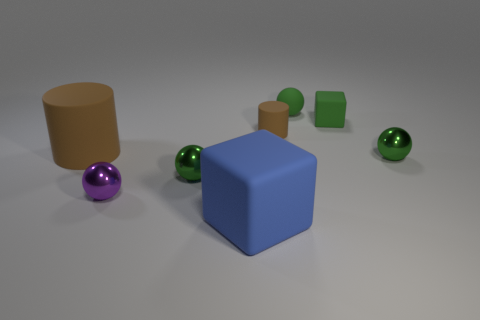Subtract all tiny green rubber balls. How many balls are left? 3 Subtract all green spheres. How many spheres are left? 1 Subtract all cyan cubes. How many purple cylinders are left? 0 Subtract all brown spheres. Subtract all yellow cubes. How many spheres are left? 4 Subtract all green metal objects. Subtract all small brown matte objects. How many objects are left? 5 Add 8 green cubes. How many green cubes are left? 9 Add 8 tiny brown cylinders. How many tiny brown cylinders exist? 9 Add 1 purple shiny cylinders. How many objects exist? 9 Subtract 0 brown blocks. How many objects are left? 8 Subtract all blocks. How many objects are left? 6 